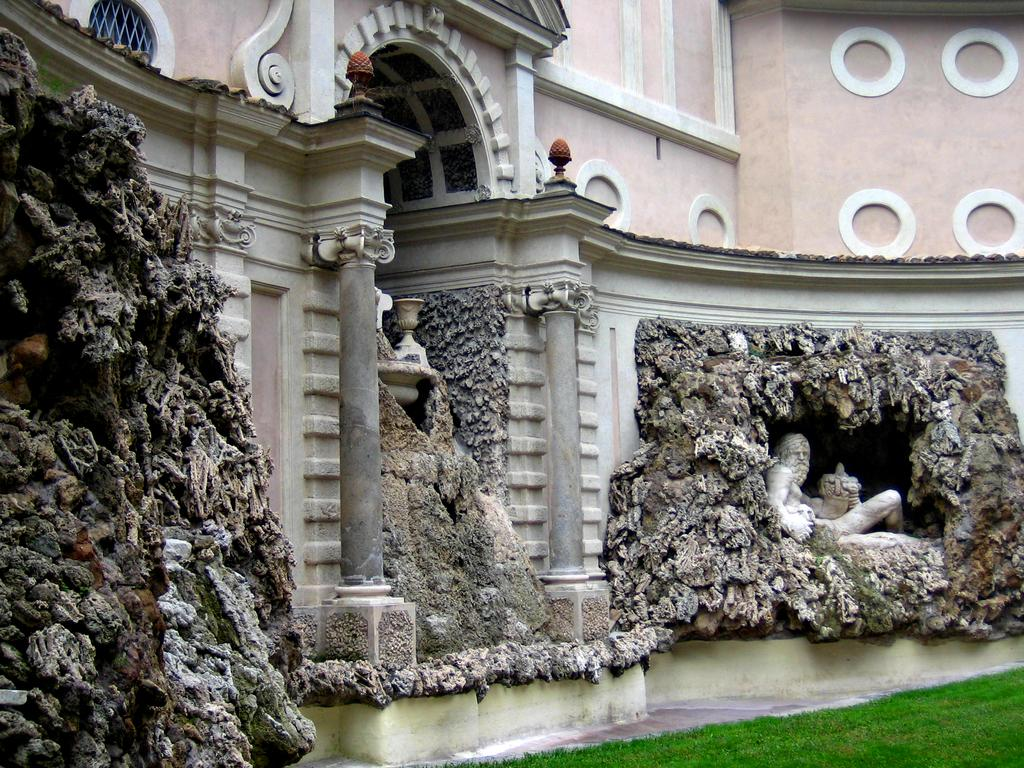What is the main subject of the image? There is a sculpture in the image. What type of natural environment is visible in the image? There is grass in the image. What type of structure can be seen in the image? There is a building with pillars in the image. How many ducks are sitting on the sculpture in the image? There are no ducks present in the image; it features a sculpture, grass, and a building with pillars. What type of doll is placed next to the building in the image? There is no doll present in the image; it features a sculpture, grass, and a building with pillars. 